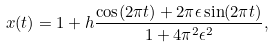Convert formula to latex. <formula><loc_0><loc_0><loc_500><loc_500>x ( t ) = 1 + h \frac { \cos ( 2 \pi t ) + 2 \pi \epsilon \sin ( 2 \pi t ) } { 1 + 4 \pi ^ { 2 } \epsilon ^ { 2 } } ,</formula> 